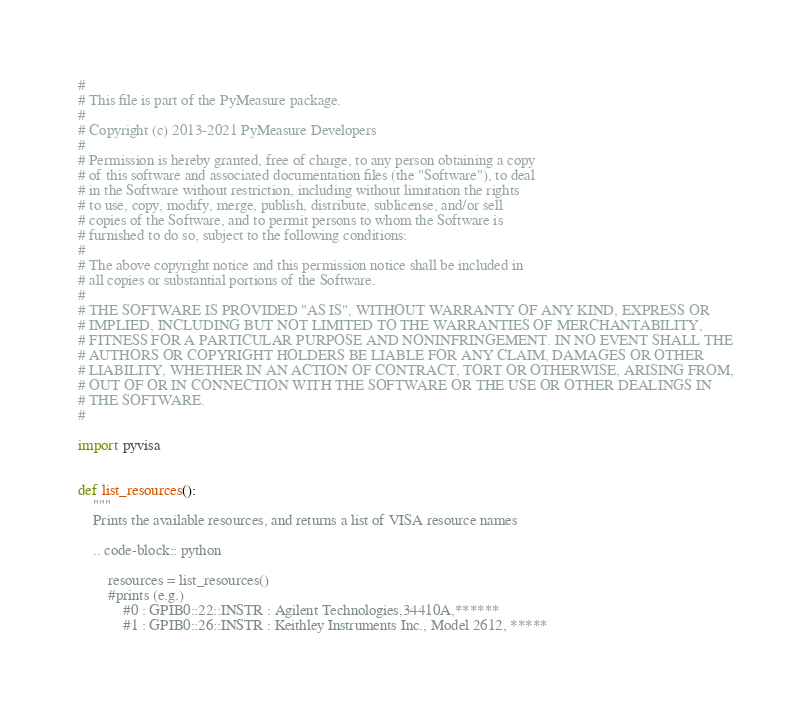Convert code to text. <code><loc_0><loc_0><loc_500><loc_500><_Python_>#
# This file is part of the PyMeasure package.
#
# Copyright (c) 2013-2021 PyMeasure Developers
#
# Permission is hereby granted, free of charge, to any person obtaining a copy
# of this software and associated documentation files (the "Software"), to deal
# in the Software without restriction, including without limitation the rights
# to use, copy, modify, merge, publish, distribute, sublicense, and/or sell
# copies of the Software, and to permit persons to whom the Software is
# furnished to do so, subject to the following conditions:
#
# The above copyright notice and this permission notice shall be included in
# all copies or substantial portions of the Software.
#
# THE SOFTWARE IS PROVIDED "AS IS", WITHOUT WARRANTY OF ANY KIND, EXPRESS OR
# IMPLIED, INCLUDING BUT NOT LIMITED TO THE WARRANTIES OF MERCHANTABILITY,
# FITNESS FOR A PARTICULAR PURPOSE AND NONINFRINGEMENT. IN NO EVENT SHALL THE
# AUTHORS OR COPYRIGHT HOLDERS BE LIABLE FOR ANY CLAIM, DAMAGES OR OTHER
# LIABILITY, WHETHER IN AN ACTION OF CONTRACT, TORT OR OTHERWISE, ARISING FROM,
# OUT OF OR IN CONNECTION WITH THE SOFTWARE OR THE USE OR OTHER DEALINGS IN
# THE SOFTWARE.
#

import pyvisa


def list_resources():
    """
    Prints the available resources, and returns a list of VISA resource names

    .. code-block:: python

        resources = list_resources()
        #prints (e.g.)
            #0 : GPIB0::22::INSTR : Agilent Technologies,34410A,******
            #1 : GPIB0::26::INSTR : Keithley Instruments Inc., Model 2612, *****</code> 